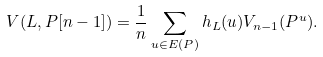Convert formula to latex. <formula><loc_0><loc_0><loc_500><loc_500>V ( L , P [ n - 1 ] ) = \frac { 1 } { n } \sum _ { u \in E ( P ) } h _ { L } ( u ) V _ { n - 1 } ( P ^ { u } ) .</formula> 